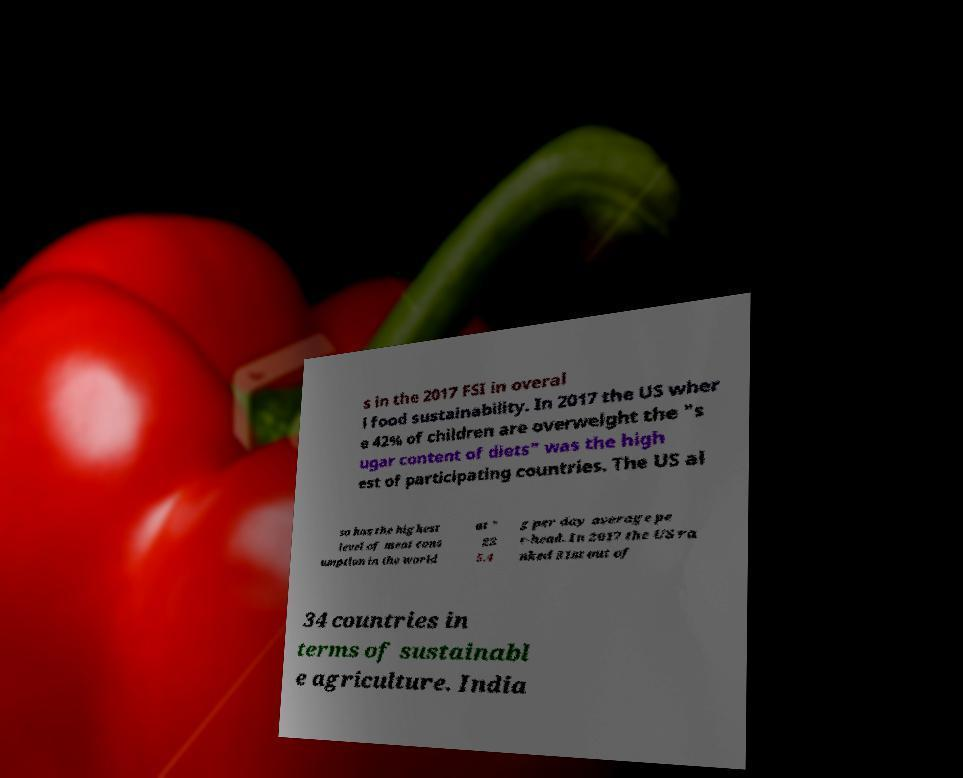Can you read and provide the text displayed in the image?This photo seems to have some interesting text. Can you extract and type it out for me? s in the 2017 FSI in overal l food sustainability. In 2017 the US wher e 42% of children are overweight the "s ugar content of diets" was the high est of participating countries. The US al so has the highest level of meat cons umption in the world at " 22 5.4 g per day average pe r-head. In 2017 the US ra nked 31st out of 34 countries in terms of sustainabl e agriculture. India 